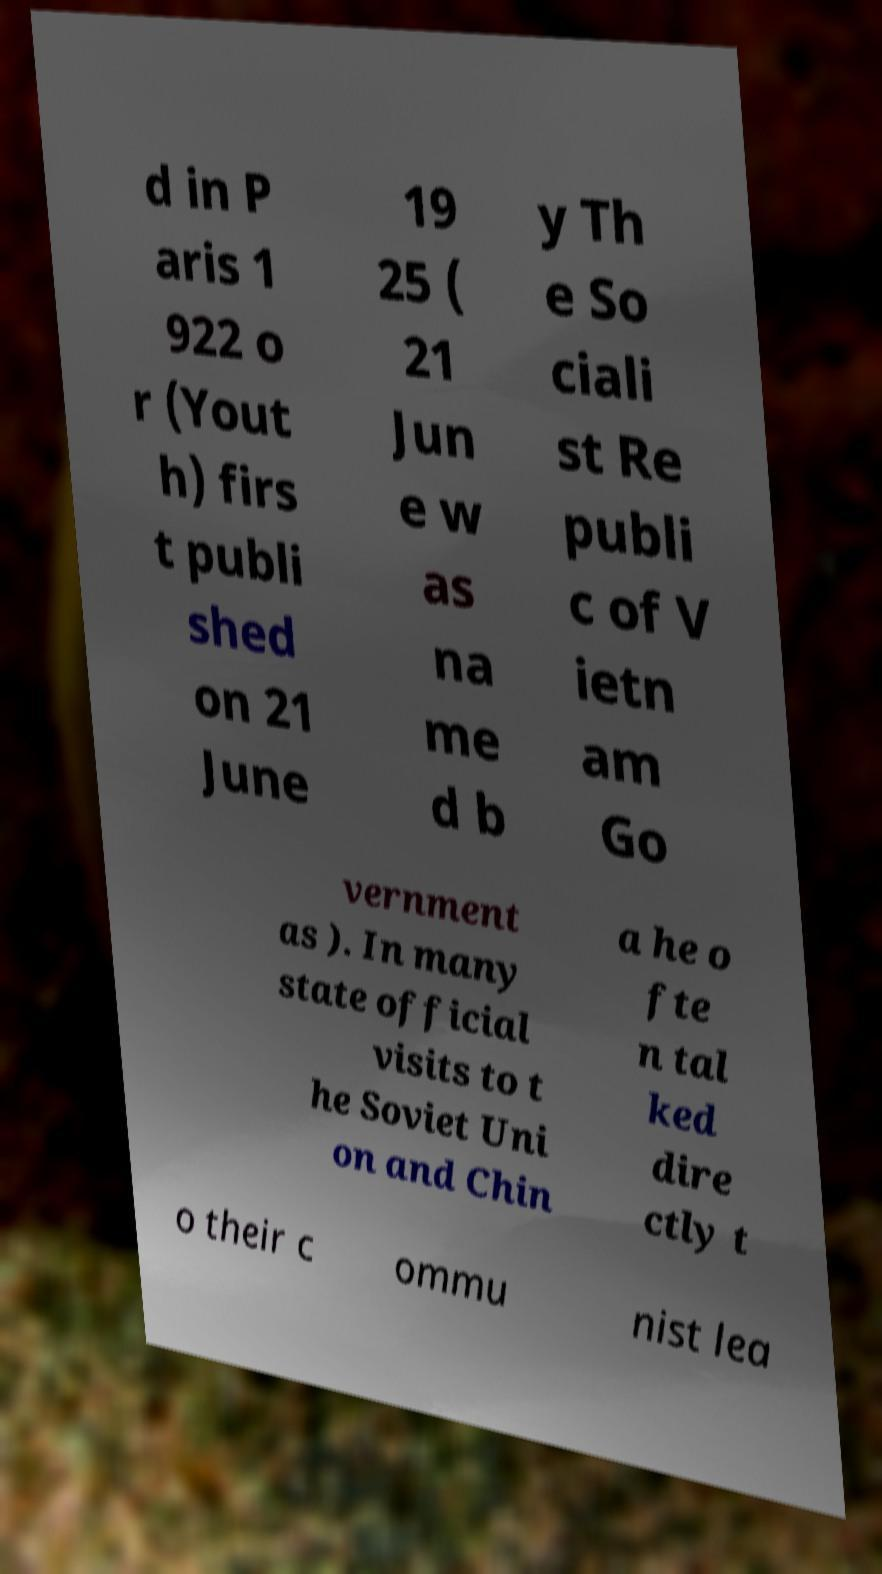Could you extract and type out the text from this image? d in P aris 1 922 o r (Yout h) firs t publi shed on 21 June 19 25 ( 21 Jun e w as na me d b y Th e So ciali st Re publi c of V ietn am Go vernment as ). In many state official visits to t he Soviet Uni on and Chin a he o fte n tal ked dire ctly t o their c ommu nist lea 